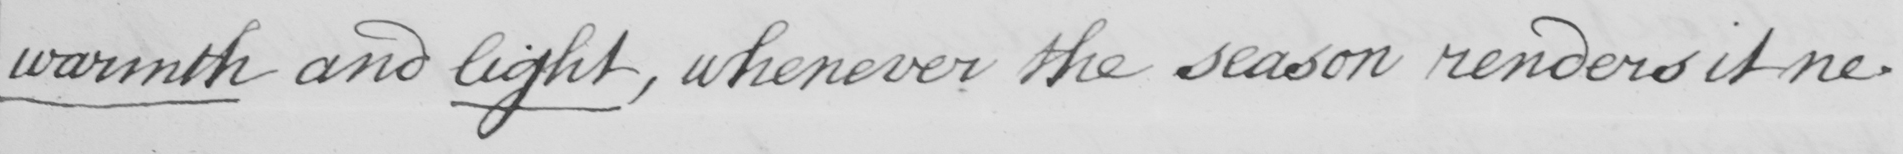Please transcribe the handwritten text in this image. warmth and light, whenever the season renders it ne- 